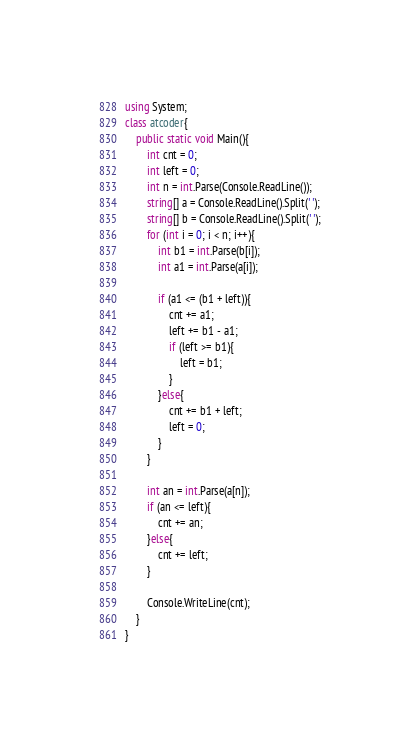<code> <loc_0><loc_0><loc_500><loc_500><_C#_>using System;
class atcoder{
    public static void Main(){
        int cnt = 0;
        int left = 0;
        int n = int.Parse(Console.ReadLine());
        string[] a = Console.ReadLine().Split(' ');
        string[] b = Console.ReadLine().Split(' ');
        for (int i = 0; i < n; i++){
            int b1 = int.Parse(b[i]);
            int a1 = int.Parse(a[i]);

            if (a1 <= (b1 + left)){
                cnt += a1;
                left += b1 - a1;
                if (left >= b1){
                    left = b1;
                }
            }else{
                cnt += b1 + left;
                left = 0;
            }
        }

        int an = int.Parse(a[n]);
        if (an <= left){
            cnt += an;
        }else{
            cnt += left;
        }

        Console.WriteLine(cnt);
    }
}</code> 